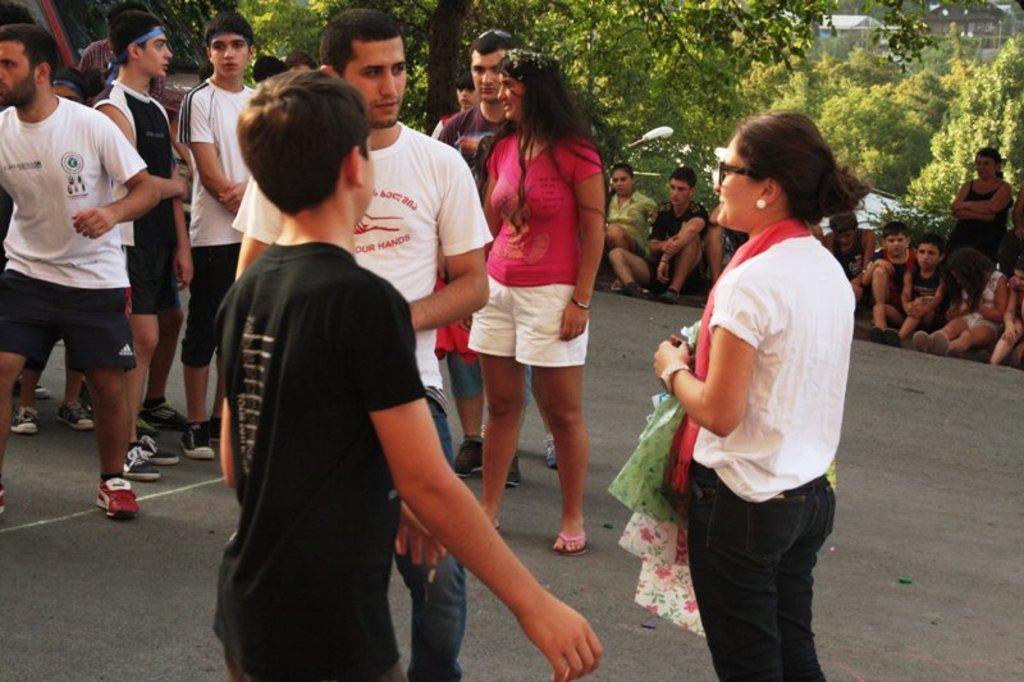Describe this image in one or two sentences. There are people in the foreground area of the image, there are people sitting, trees, houses and a lamp pole in the background. 